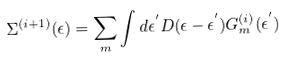Convert formula to latex. <formula><loc_0><loc_0><loc_500><loc_500>\Sigma ^ { ( i + 1 ) } ( \epsilon ) = \sum _ { m } \int d \epsilon ^ { ^ { \prime } } D ( \epsilon - \epsilon ^ { ^ { \prime } } ) G ^ { ( i ) } _ { m } ( \epsilon ^ { ^ { \prime } } )</formula> 